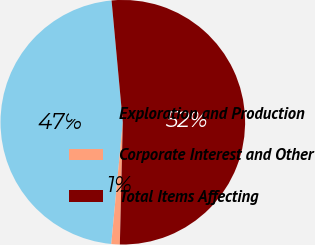Convert chart. <chart><loc_0><loc_0><loc_500><loc_500><pie_chart><fcel>Exploration and Production<fcel>Corporate Interest and Other<fcel>Total Items Affecting<nl><fcel>47.03%<fcel>1.12%<fcel>51.85%<nl></chart> 